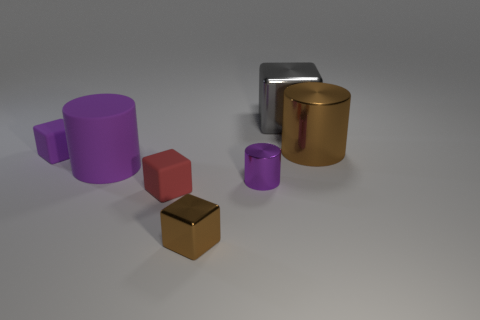Are there an equal number of small red things that are right of the small purple cylinder and small brown metallic objects that are behind the big gray metal cube?
Provide a short and direct response. Yes. Does the small rubber object behind the rubber cylinder have the same shape as the brown thing that is left of the gray metal thing?
Your answer should be very brief. Yes. There is a purple thing that is made of the same material as the large cube; what is its shape?
Your response must be concise. Cylinder. Are there the same number of big gray metal cubes that are in front of the purple metallic cylinder and gray rubber cylinders?
Offer a very short reply. Yes. Does the brown object that is behind the purple shiny cylinder have the same material as the large thing that is left of the gray metal block?
Ensure brevity in your answer.  No. There is a large thing in front of the block that is left of the tiny red matte cube; what shape is it?
Your response must be concise. Cylinder. What is the color of the cube that is made of the same material as the tiny brown object?
Ensure brevity in your answer.  Gray. Does the big rubber thing have the same color as the small shiny cylinder?
Give a very brief answer. Yes. What shape is the purple metallic thing that is the same size as the purple cube?
Your response must be concise. Cylinder. What size is the purple shiny cylinder?
Offer a terse response. Small. 